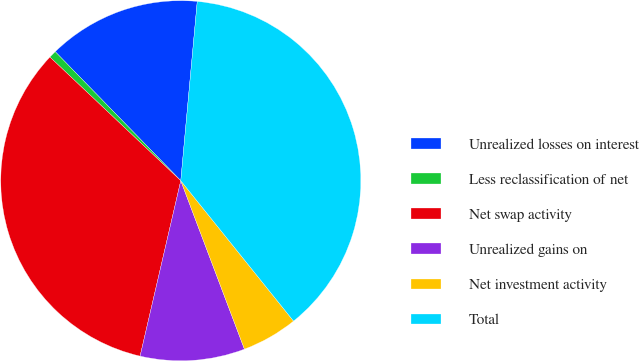Convert chart to OTSL. <chart><loc_0><loc_0><loc_500><loc_500><pie_chart><fcel>Unrealized losses on interest<fcel>Less reclassification of net<fcel>Net swap activity<fcel>Unrealized gains on<fcel>Net investment activity<fcel>Total<nl><fcel>13.74%<fcel>0.67%<fcel>33.42%<fcel>9.38%<fcel>5.02%<fcel>37.77%<nl></chart> 